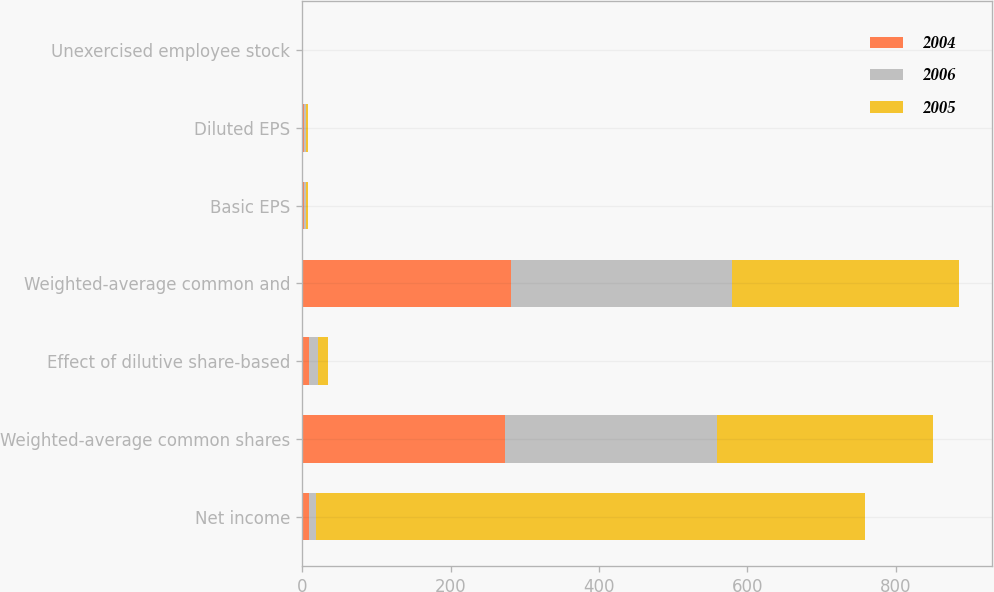Convert chart. <chart><loc_0><loc_0><loc_500><loc_500><stacked_bar_chart><ecel><fcel>Net income<fcel>Weighted-average common shares<fcel>Effect of dilutive share-based<fcel>Weighted-average common and<fcel>Basic EPS<fcel>Diluted EPS<fcel>Unexercised employee stock<nl><fcel>2004<fcel>9<fcel>273<fcel>9<fcel>282<fcel>3.02<fcel>2.92<fcel>0.1<nl><fcel>2006<fcel>9<fcel>286<fcel>12<fcel>298<fcel>2.66<fcel>2.55<fcel>0.5<nl><fcel>2005<fcel>740<fcel>291<fcel>14<fcel>305<fcel>2.54<fcel>2.42<fcel>0.4<nl></chart> 